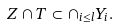Convert formula to latex. <formula><loc_0><loc_0><loc_500><loc_500>Z \cap T \subset \cap _ { i \leq l } Y _ { i } .</formula> 